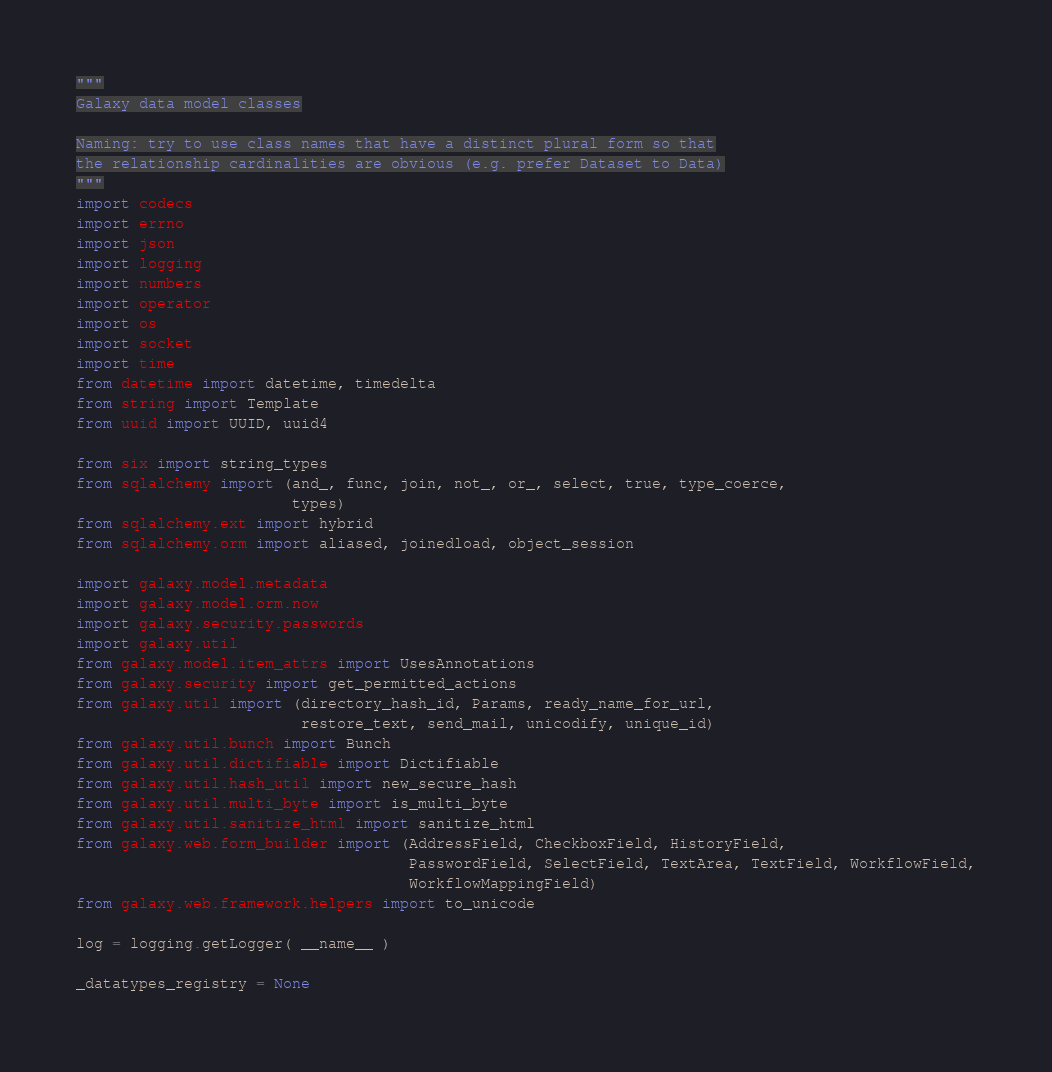Convert code to text. <code><loc_0><loc_0><loc_500><loc_500><_Python_>"""
Galaxy data model classes

Naming: try to use class names that have a distinct plural form so that
the relationship cardinalities are obvious (e.g. prefer Dataset to Data)
"""
import codecs
import errno
import json
import logging
import numbers
import operator
import os
import socket
import time
from datetime import datetime, timedelta
from string import Template
from uuid import UUID, uuid4

from six import string_types
from sqlalchemy import (and_, func, join, not_, or_, select, true, type_coerce,
                        types)
from sqlalchemy.ext import hybrid
from sqlalchemy.orm import aliased, joinedload, object_session

import galaxy.model.metadata
import galaxy.model.orm.now
import galaxy.security.passwords
import galaxy.util
from galaxy.model.item_attrs import UsesAnnotations
from galaxy.security import get_permitted_actions
from galaxy.util import (directory_hash_id, Params, ready_name_for_url,
                         restore_text, send_mail, unicodify, unique_id)
from galaxy.util.bunch import Bunch
from galaxy.util.dictifiable import Dictifiable
from galaxy.util.hash_util import new_secure_hash
from galaxy.util.multi_byte import is_multi_byte
from galaxy.util.sanitize_html import sanitize_html
from galaxy.web.form_builder import (AddressField, CheckboxField, HistoryField,
                                     PasswordField, SelectField, TextArea, TextField, WorkflowField,
                                     WorkflowMappingField)
from galaxy.web.framework.helpers import to_unicode

log = logging.getLogger( __name__ )

_datatypes_registry = None
</code> 